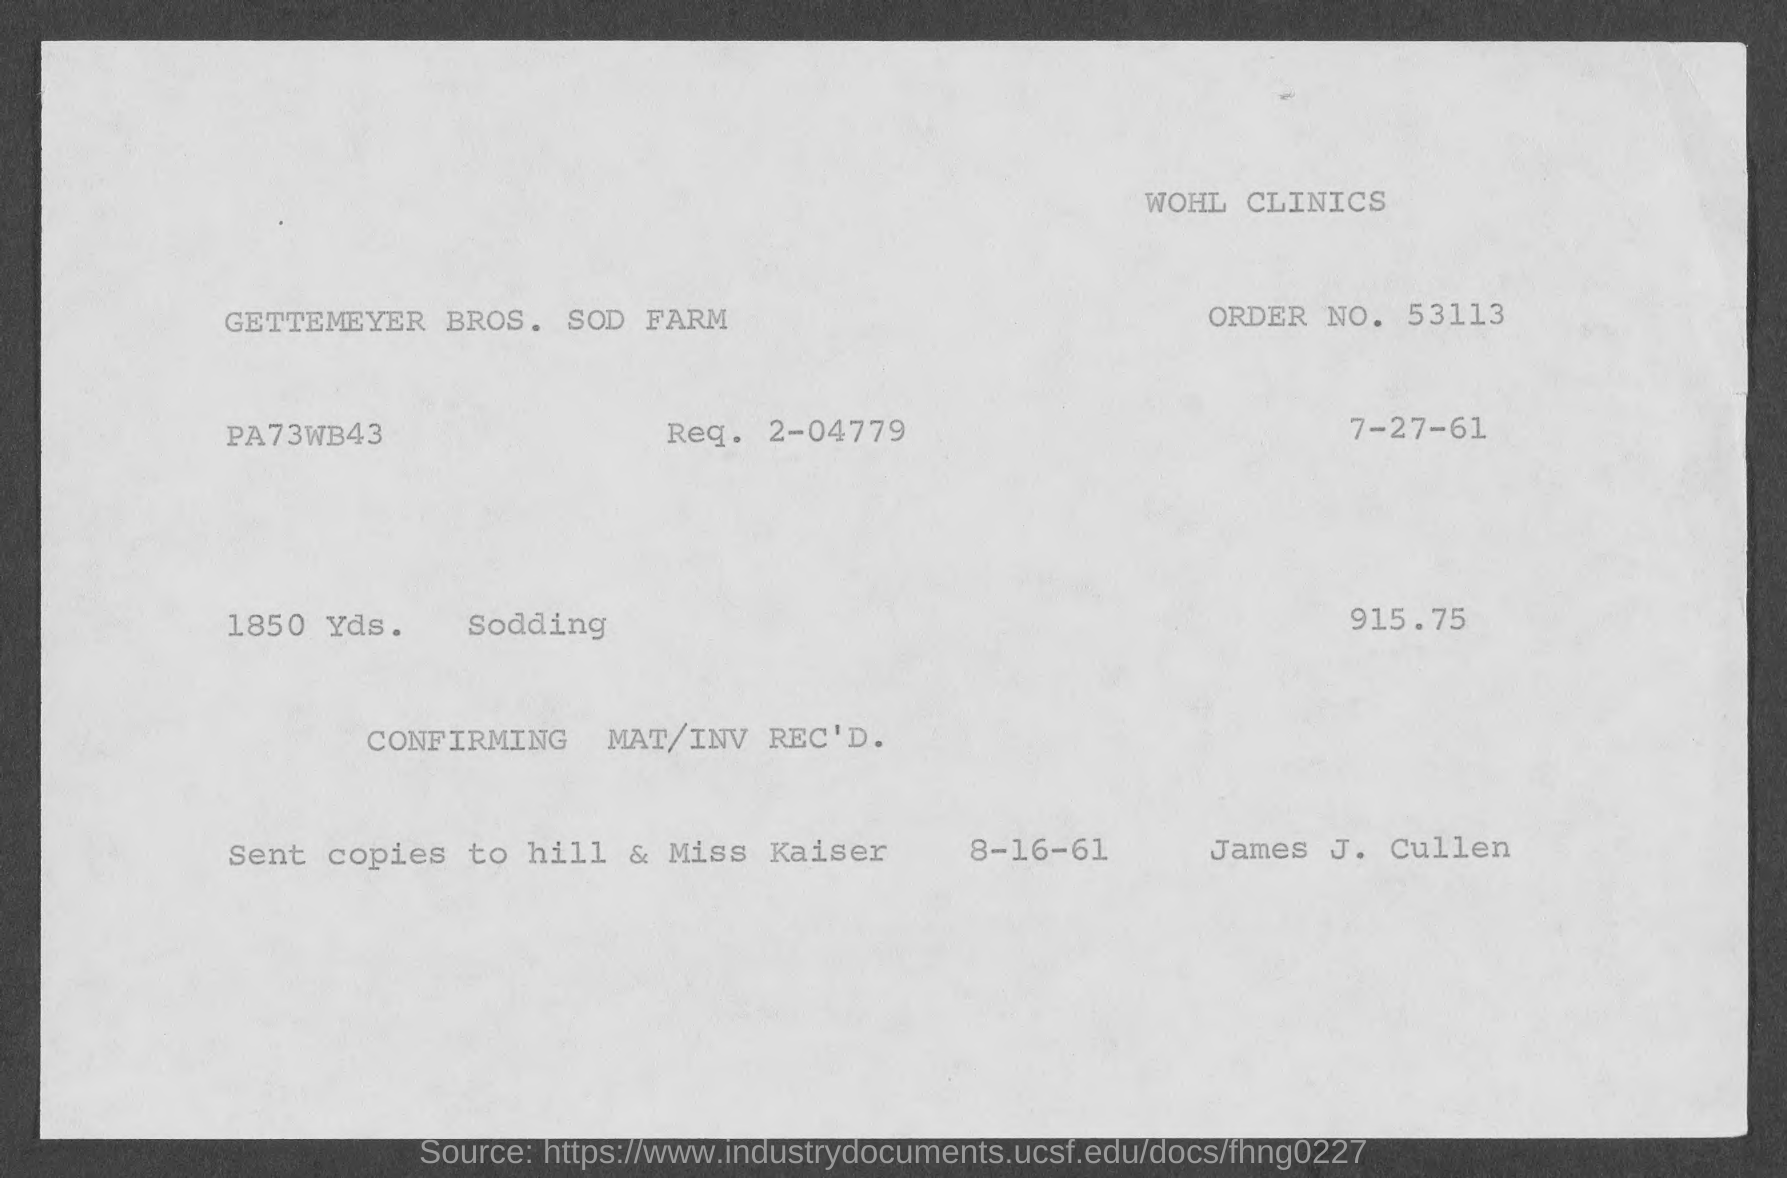Specify some key components in this picture. The request number specified in the invoice is 2-04779. The order number provided on the invoice is 53113. The invoice amount, as per the document, is 915.75... The issued date of the invoice is July 27, 1961. 